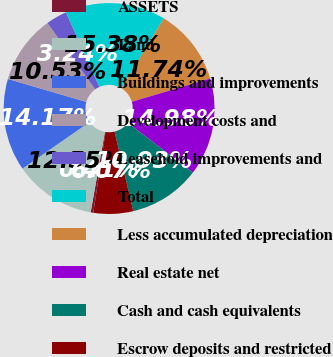Convert chart to OTSL. <chart><loc_0><loc_0><loc_500><loc_500><pie_chart><fcel>ASSETS<fcel>Land<fcel>Buildings and improvements<fcel>Development costs and<fcel>Leasehold improvements and<fcel>Total<fcel>Less accumulated depreciation<fcel>Real estate net<fcel>Cash and cash equivalents<fcel>Escrow deposits and restricted<nl><fcel>0.41%<fcel>12.55%<fcel>14.17%<fcel>10.53%<fcel>3.24%<fcel>15.38%<fcel>11.74%<fcel>14.98%<fcel>10.93%<fcel>6.07%<nl></chart> 